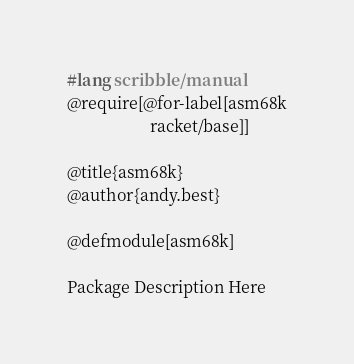<code> <loc_0><loc_0><loc_500><loc_500><_Racket_>#lang scribble/manual
@require[@for-label[asm68k
                    racket/base]]

@title{asm68k}
@author{andy.best}

@defmodule[asm68k]

Package Description Here
</code> 